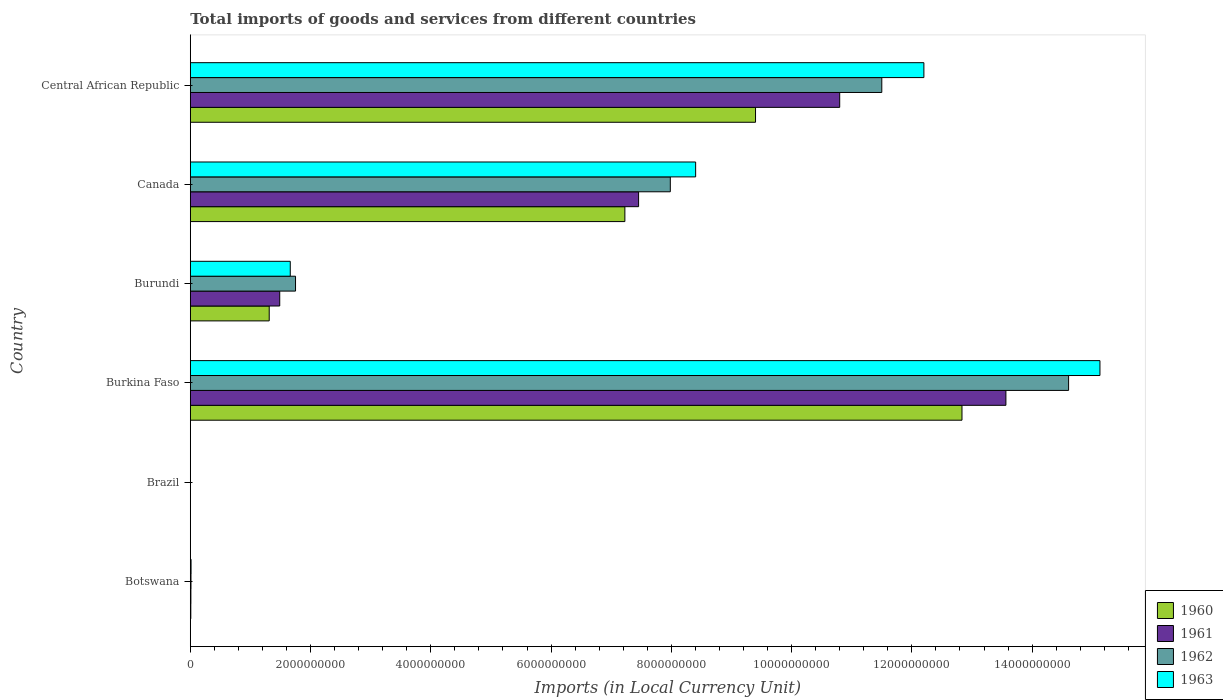How many groups of bars are there?
Keep it short and to the point. 6. How many bars are there on the 3rd tick from the bottom?
Ensure brevity in your answer.  4. What is the label of the 2nd group of bars from the top?
Your answer should be compact. Canada. What is the Amount of goods and services imports in 1963 in Brazil?
Offer a terse response. 0. Across all countries, what is the maximum Amount of goods and services imports in 1960?
Provide a succinct answer. 1.28e+1. Across all countries, what is the minimum Amount of goods and services imports in 1962?
Your response must be concise. 0. In which country was the Amount of goods and services imports in 1960 maximum?
Give a very brief answer. Burkina Faso. What is the total Amount of goods and services imports in 1960 in the graph?
Provide a succinct answer. 3.08e+1. What is the difference between the Amount of goods and services imports in 1960 in Burundi and that in Canada?
Your answer should be compact. -5.91e+09. What is the difference between the Amount of goods and services imports in 1962 in Botswana and the Amount of goods and services imports in 1960 in Burundi?
Offer a very short reply. -1.30e+09. What is the average Amount of goods and services imports in 1961 per country?
Make the answer very short. 5.55e+09. What is the difference between the Amount of goods and services imports in 1961 and Amount of goods and services imports in 1963 in Brazil?
Offer a very short reply. -0. What is the ratio of the Amount of goods and services imports in 1960 in Botswana to that in Burundi?
Provide a short and direct response. 0.01. What is the difference between the highest and the second highest Amount of goods and services imports in 1960?
Offer a very short reply. 3.43e+09. What is the difference between the highest and the lowest Amount of goods and services imports in 1961?
Your response must be concise. 1.36e+1. In how many countries, is the Amount of goods and services imports in 1963 greater than the average Amount of goods and services imports in 1963 taken over all countries?
Give a very brief answer. 3. Is it the case that in every country, the sum of the Amount of goods and services imports in 1960 and Amount of goods and services imports in 1961 is greater than the sum of Amount of goods and services imports in 1963 and Amount of goods and services imports in 1962?
Ensure brevity in your answer.  No. What does the 4th bar from the top in Canada represents?
Give a very brief answer. 1960. Is it the case that in every country, the sum of the Amount of goods and services imports in 1961 and Amount of goods and services imports in 1963 is greater than the Amount of goods and services imports in 1960?
Your answer should be very brief. Yes. How many bars are there?
Offer a terse response. 24. How many countries are there in the graph?
Your response must be concise. 6. What is the difference between two consecutive major ticks on the X-axis?
Your response must be concise. 2.00e+09. Are the values on the major ticks of X-axis written in scientific E-notation?
Keep it short and to the point. No. Does the graph contain any zero values?
Ensure brevity in your answer.  No. Does the graph contain grids?
Offer a very short reply. No. How many legend labels are there?
Offer a terse response. 4. What is the title of the graph?
Your answer should be very brief. Total imports of goods and services from different countries. Does "1997" appear as one of the legend labels in the graph?
Ensure brevity in your answer.  No. What is the label or title of the X-axis?
Offer a terse response. Imports (in Local Currency Unit). What is the label or title of the Y-axis?
Provide a short and direct response. Country. What is the Imports (in Local Currency Unit) of 1960 in Botswana?
Ensure brevity in your answer.  8.60e+06. What is the Imports (in Local Currency Unit) of 1962 in Botswana?
Offer a very short reply. 1.14e+07. What is the Imports (in Local Currency Unit) of 1963 in Botswana?
Offer a terse response. 1.29e+07. What is the Imports (in Local Currency Unit) in 1960 in Brazil?
Keep it short and to the point. 7.33493e-5. What is the Imports (in Local Currency Unit) of 1961 in Brazil?
Offer a terse response. 0. What is the Imports (in Local Currency Unit) of 1962 in Brazil?
Your answer should be very brief. 0. What is the Imports (in Local Currency Unit) in 1963 in Brazil?
Ensure brevity in your answer.  0. What is the Imports (in Local Currency Unit) of 1960 in Burkina Faso?
Ensure brevity in your answer.  1.28e+1. What is the Imports (in Local Currency Unit) of 1961 in Burkina Faso?
Keep it short and to the point. 1.36e+1. What is the Imports (in Local Currency Unit) of 1962 in Burkina Faso?
Your response must be concise. 1.46e+1. What is the Imports (in Local Currency Unit) in 1963 in Burkina Faso?
Your response must be concise. 1.51e+1. What is the Imports (in Local Currency Unit) in 1960 in Burundi?
Your answer should be very brief. 1.31e+09. What is the Imports (in Local Currency Unit) of 1961 in Burundi?
Ensure brevity in your answer.  1.49e+09. What is the Imports (in Local Currency Unit) of 1962 in Burundi?
Your response must be concise. 1.75e+09. What is the Imports (in Local Currency Unit) in 1963 in Burundi?
Give a very brief answer. 1.66e+09. What is the Imports (in Local Currency Unit) in 1960 in Canada?
Ensure brevity in your answer.  7.23e+09. What is the Imports (in Local Currency Unit) in 1961 in Canada?
Make the answer very short. 7.46e+09. What is the Imports (in Local Currency Unit) of 1962 in Canada?
Keep it short and to the point. 7.98e+09. What is the Imports (in Local Currency Unit) of 1963 in Canada?
Offer a terse response. 8.40e+09. What is the Imports (in Local Currency Unit) in 1960 in Central African Republic?
Your answer should be compact. 9.40e+09. What is the Imports (in Local Currency Unit) of 1961 in Central African Republic?
Keep it short and to the point. 1.08e+1. What is the Imports (in Local Currency Unit) in 1962 in Central African Republic?
Your response must be concise. 1.15e+1. What is the Imports (in Local Currency Unit) in 1963 in Central African Republic?
Your answer should be compact. 1.22e+1. Across all countries, what is the maximum Imports (in Local Currency Unit) in 1960?
Keep it short and to the point. 1.28e+1. Across all countries, what is the maximum Imports (in Local Currency Unit) in 1961?
Provide a succinct answer. 1.36e+1. Across all countries, what is the maximum Imports (in Local Currency Unit) in 1962?
Your answer should be very brief. 1.46e+1. Across all countries, what is the maximum Imports (in Local Currency Unit) in 1963?
Give a very brief answer. 1.51e+1. Across all countries, what is the minimum Imports (in Local Currency Unit) of 1960?
Ensure brevity in your answer.  7.33493e-5. Across all countries, what is the minimum Imports (in Local Currency Unit) in 1961?
Ensure brevity in your answer.  0. Across all countries, what is the minimum Imports (in Local Currency Unit) of 1962?
Your response must be concise. 0. Across all countries, what is the minimum Imports (in Local Currency Unit) in 1963?
Provide a short and direct response. 0. What is the total Imports (in Local Currency Unit) in 1960 in the graph?
Your answer should be compact. 3.08e+1. What is the total Imports (in Local Currency Unit) of 1961 in the graph?
Make the answer very short. 3.33e+1. What is the total Imports (in Local Currency Unit) of 1962 in the graph?
Give a very brief answer. 3.59e+1. What is the total Imports (in Local Currency Unit) of 1963 in the graph?
Your answer should be very brief. 3.74e+1. What is the difference between the Imports (in Local Currency Unit) of 1960 in Botswana and that in Brazil?
Make the answer very short. 8.60e+06. What is the difference between the Imports (in Local Currency Unit) in 1961 in Botswana and that in Brazil?
Your response must be concise. 1.00e+07. What is the difference between the Imports (in Local Currency Unit) in 1962 in Botswana and that in Brazil?
Make the answer very short. 1.14e+07. What is the difference between the Imports (in Local Currency Unit) of 1963 in Botswana and that in Brazil?
Your answer should be very brief. 1.29e+07. What is the difference between the Imports (in Local Currency Unit) in 1960 in Botswana and that in Burkina Faso?
Provide a short and direct response. -1.28e+1. What is the difference between the Imports (in Local Currency Unit) of 1961 in Botswana and that in Burkina Faso?
Keep it short and to the point. -1.36e+1. What is the difference between the Imports (in Local Currency Unit) of 1962 in Botswana and that in Burkina Faso?
Your response must be concise. -1.46e+1. What is the difference between the Imports (in Local Currency Unit) in 1963 in Botswana and that in Burkina Faso?
Provide a succinct answer. -1.51e+1. What is the difference between the Imports (in Local Currency Unit) of 1960 in Botswana and that in Burundi?
Give a very brief answer. -1.30e+09. What is the difference between the Imports (in Local Currency Unit) of 1961 in Botswana and that in Burundi?
Ensure brevity in your answer.  -1.48e+09. What is the difference between the Imports (in Local Currency Unit) in 1962 in Botswana and that in Burundi?
Provide a short and direct response. -1.74e+09. What is the difference between the Imports (in Local Currency Unit) in 1963 in Botswana and that in Burundi?
Give a very brief answer. -1.65e+09. What is the difference between the Imports (in Local Currency Unit) in 1960 in Botswana and that in Canada?
Make the answer very short. -7.22e+09. What is the difference between the Imports (in Local Currency Unit) in 1961 in Botswana and that in Canada?
Ensure brevity in your answer.  -7.45e+09. What is the difference between the Imports (in Local Currency Unit) in 1962 in Botswana and that in Canada?
Your answer should be very brief. -7.97e+09. What is the difference between the Imports (in Local Currency Unit) in 1963 in Botswana and that in Canada?
Your answer should be very brief. -8.39e+09. What is the difference between the Imports (in Local Currency Unit) in 1960 in Botswana and that in Central African Republic?
Keep it short and to the point. -9.39e+09. What is the difference between the Imports (in Local Currency Unit) in 1961 in Botswana and that in Central African Republic?
Offer a terse response. -1.08e+1. What is the difference between the Imports (in Local Currency Unit) in 1962 in Botswana and that in Central African Republic?
Offer a very short reply. -1.15e+1. What is the difference between the Imports (in Local Currency Unit) in 1963 in Botswana and that in Central African Republic?
Ensure brevity in your answer.  -1.22e+1. What is the difference between the Imports (in Local Currency Unit) in 1960 in Brazil and that in Burkina Faso?
Provide a succinct answer. -1.28e+1. What is the difference between the Imports (in Local Currency Unit) of 1961 in Brazil and that in Burkina Faso?
Provide a succinct answer. -1.36e+1. What is the difference between the Imports (in Local Currency Unit) in 1962 in Brazil and that in Burkina Faso?
Give a very brief answer. -1.46e+1. What is the difference between the Imports (in Local Currency Unit) of 1963 in Brazil and that in Burkina Faso?
Offer a terse response. -1.51e+1. What is the difference between the Imports (in Local Currency Unit) in 1960 in Brazil and that in Burundi?
Provide a succinct answer. -1.31e+09. What is the difference between the Imports (in Local Currency Unit) of 1961 in Brazil and that in Burundi?
Provide a short and direct response. -1.49e+09. What is the difference between the Imports (in Local Currency Unit) in 1962 in Brazil and that in Burundi?
Offer a terse response. -1.75e+09. What is the difference between the Imports (in Local Currency Unit) in 1963 in Brazil and that in Burundi?
Offer a very short reply. -1.66e+09. What is the difference between the Imports (in Local Currency Unit) of 1960 in Brazil and that in Canada?
Make the answer very short. -7.23e+09. What is the difference between the Imports (in Local Currency Unit) in 1961 in Brazil and that in Canada?
Offer a very short reply. -7.46e+09. What is the difference between the Imports (in Local Currency Unit) in 1962 in Brazil and that in Canada?
Offer a terse response. -7.98e+09. What is the difference between the Imports (in Local Currency Unit) in 1963 in Brazil and that in Canada?
Make the answer very short. -8.40e+09. What is the difference between the Imports (in Local Currency Unit) in 1960 in Brazil and that in Central African Republic?
Provide a succinct answer. -9.40e+09. What is the difference between the Imports (in Local Currency Unit) of 1961 in Brazil and that in Central African Republic?
Provide a short and direct response. -1.08e+1. What is the difference between the Imports (in Local Currency Unit) of 1962 in Brazil and that in Central African Republic?
Your answer should be compact. -1.15e+1. What is the difference between the Imports (in Local Currency Unit) of 1963 in Brazil and that in Central African Republic?
Give a very brief answer. -1.22e+1. What is the difference between the Imports (in Local Currency Unit) in 1960 in Burkina Faso and that in Burundi?
Offer a terse response. 1.15e+1. What is the difference between the Imports (in Local Currency Unit) in 1961 in Burkina Faso and that in Burundi?
Your response must be concise. 1.21e+1. What is the difference between the Imports (in Local Currency Unit) of 1962 in Burkina Faso and that in Burundi?
Provide a short and direct response. 1.29e+1. What is the difference between the Imports (in Local Currency Unit) of 1963 in Burkina Faso and that in Burundi?
Offer a terse response. 1.35e+1. What is the difference between the Imports (in Local Currency Unit) of 1960 in Burkina Faso and that in Canada?
Offer a terse response. 5.61e+09. What is the difference between the Imports (in Local Currency Unit) of 1961 in Burkina Faso and that in Canada?
Your answer should be compact. 6.11e+09. What is the difference between the Imports (in Local Currency Unit) in 1962 in Burkina Faso and that in Canada?
Provide a succinct answer. 6.62e+09. What is the difference between the Imports (in Local Currency Unit) of 1963 in Burkina Faso and that in Canada?
Ensure brevity in your answer.  6.72e+09. What is the difference between the Imports (in Local Currency Unit) of 1960 in Burkina Faso and that in Central African Republic?
Offer a terse response. 3.43e+09. What is the difference between the Imports (in Local Currency Unit) of 1961 in Burkina Faso and that in Central African Republic?
Your answer should be very brief. 2.76e+09. What is the difference between the Imports (in Local Currency Unit) of 1962 in Burkina Faso and that in Central African Republic?
Offer a terse response. 3.11e+09. What is the difference between the Imports (in Local Currency Unit) of 1963 in Burkina Faso and that in Central African Republic?
Keep it short and to the point. 2.93e+09. What is the difference between the Imports (in Local Currency Unit) of 1960 in Burundi and that in Canada?
Your response must be concise. -5.91e+09. What is the difference between the Imports (in Local Currency Unit) in 1961 in Burundi and that in Canada?
Offer a very short reply. -5.97e+09. What is the difference between the Imports (in Local Currency Unit) of 1962 in Burundi and that in Canada?
Give a very brief answer. -6.23e+09. What is the difference between the Imports (in Local Currency Unit) in 1963 in Burundi and that in Canada?
Give a very brief answer. -6.74e+09. What is the difference between the Imports (in Local Currency Unit) of 1960 in Burundi and that in Central African Republic?
Offer a terse response. -8.09e+09. What is the difference between the Imports (in Local Currency Unit) in 1961 in Burundi and that in Central African Republic?
Give a very brief answer. -9.31e+09. What is the difference between the Imports (in Local Currency Unit) in 1962 in Burundi and that in Central African Republic?
Offer a terse response. -9.75e+09. What is the difference between the Imports (in Local Currency Unit) of 1963 in Burundi and that in Central African Republic?
Your answer should be very brief. -1.05e+1. What is the difference between the Imports (in Local Currency Unit) in 1960 in Canada and that in Central African Republic?
Your answer should be compact. -2.17e+09. What is the difference between the Imports (in Local Currency Unit) of 1961 in Canada and that in Central African Republic?
Offer a very short reply. -3.34e+09. What is the difference between the Imports (in Local Currency Unit) of 1962 in Canada and that in Central African Republic?
Your answer should be very brief. -3.52e+09. What is the difference between the Imports (in Local Currency Unit) in 1963 in Canada and that in Central African Republic?
Your answer should be compact. -3.80e+09. What is the difference between the Imports (in Local Currency Unit) in 1960 in Botswana and the Imports (in Local Currency Unit) in 1961 in Brazil?
Your answer should be compact. 8.60e+06. What is the difference between the Imports (in Local Currency Unit) in 1960 in Botswana and the Imports (in Local Currency Unit) in 1962 in Brazil?
Make the answer very short. 8.60e+06. What is the difference between the Imports (in Local Currency Unit) of 1960 in Botswana and the Imports (in Local Currency Unit) of 1963 in Brazil?
Offer a terse response. 8.60e+06. What is the difference between the Imports (in Local Currency Unit) of 1961 in Botswana and the Imports (in Local Currency Unit) of 1962 in Brazil?
Offer a terse response. 1.00e+07. What is the difference between the Imports (in Local Currency Unit) of 1961 in Botswana and the Imports (in Local Currency Unit) of 1963 in Brazil?
Make the answer very short. 1.00e+07. What is the difference between the Imports (in Local Currency Unit) of 1962 in Botswana and the Imports (in Local Currency Unit) of 1963 in Brazil?
Offer a terse response. 1.14e+07. What is the difference between the Imports (in Local Currency Unit) in 1960 in Botswana and the Imports (in Local Currency Unit) in 1961 in Burkina Faso?
Make the answer very short. -1.36e+1. What is the difference between the Imports (in Local Currency Unit) of 1960 in Botswana and the Imports (in Local Currency Unit) of 1962 in Burkina Faso?
Ensure brevity in your answer.  -1.46e+1. What is the difference between the Imports (in Local Currency Unit) in 1960 in Botswana and the Imports (in Local Currency Unit) in 1963 in Burkina Faso?
Ensure brevity in your answer.  -1.51e+1. What is the difference between the Imports (in Local Currency Unit) of 1961 in Botswana and the Imports (in Local Currency Unit) of 1962 in Burkina Faso?
Make the answer very short. -1.46e+1. What is the difference between the Imports (in Local Currency Unit) in 1961 in Botswana and the Imports (in Local Currency Unit) in 1963 in Burkina Faso?
Provide a succinct answer. -1.51e+1. What is the difference between the Imports (in Local Currency Unit) of 1962 in Botswana and the Imports (in Local Currency Unit) of 1963 in Burkina Faso?
Ensure brevity in your answer.  -1.51e+1. What is the difference between the Imports (in Local Currency Unit) of 1960 in Botswana and the Imports (in Local Currency Unit) of 1961 in Burundi?
Your answer should be very brief. -1.48e+09. What is the difference between the Imports (in Local Currency Unit) of 1960 in Botswana and the Imports (in Local Currency Unit) of 1962 in Burundi?
Your response must be concise. -1.74e+09. What is the difference between the Imports (in Local Currency Unit) of 1960 in Botswana and the Imports (in Local Currency Unit) of 1963 in Burundi?
Give a very brief answer. -1.65e+09. What is the difference between the Imports (in Local Currency Unit) of 1961 in Botswana and the Imports (in Local Currency Unit) of 1962 in Burundi?
Provide a succinct answer. -1.74e+09. What is the difference between the Imports (in Local Currency Unit) in 1961 in Botswana and the Imports (in Local Currency Unit) in 1963 in Burundi?
Provide a succinct answer. -1.65e+09. What is the difference between the Imports (in Local Currency Unit) of 1962 in Botswana and the Imports (in Local Currency Unit) of 1963 in Burundi?
Your response must be concise. -1.65e+09. What is the difference between the Imports (in Local Currency Unit) in 1960 in Botswana and the Imports (in Local Currency Unit) in 1961 in Canada?
Ensure brevity in your answer.  -7.45e+09. What is the difference between the Imports (in Local Currency Unit) of 1960 in Botswana and the Imports (in Local Currency Unit) of 1962 in Canada?
Your answer should be compact. -7.97e+09. What is the difference between the Imports (in Local Currency Unit) in 1960 in Botswana and the Imports (in Local Currency Unit) in 1963 in Canada?
Give a very brief answer. -8.40e+09. What is the difference between the Imports (in Local Currency Unit) of 1961 in Botswana and the Imports (in Local Currency Unit) of 1962 in Canada?
Give a very brief answer. -7.97e+09. What is the difference between the Imports (in Local Currency Unit) of 1961 in Botswana and the Imports (in Local Currency Unit) of 1963 in Canada?
Offer a very short reply. -8.39e+09. What is the difference between the Imports (in Local Currency Unit) in 1962 in Botswana and the Imports (in Local Currency Unit) in 1963 in Canada?
Ensure brevity in your answer.  -8.39e+09. What is the difference between the Imports (in Local Currency Unit) of 1960 in Botswana and the Imports (in Local Currency Unit) of 1961 in Central African Republic?
Make the answer very short. -1.08e+1. What is the difference between the Imports (in Local Currency Unit) in 1960 in Botswana and the Imports (in Local Currency Unit) in 1962 in Central African Republic?
Offer a terse response. -1.15e+1. What is the difference between the Imports (in Local Currency Unit) of 1960 in Botswana and the Imports (in Local Currency Unit) of 1963 in Central African Republic?
Ensure brevity in your answer.  -1.22e+1. What is the difference between the Imports (in Local Currency Unit) in 1961 in Botswana and the Imports (in Local Currency Unit) in 1962 in Central African Republic?
Your response must be concise. -1.15e+1. What is the difference between the Imports (in Local Currency Unit) in 1961 in Botswana and the Imports (in Local Currency Unit) in 1963 in Central African Republic?
Make the answer very short. -1.22e+1. What is the difference between the Imports (in Local Currency Unit) in 1962 in Botswana and the Imports (in Local Currency Unit) in 1963 in Central African Republic?
Provide a short and direct response. -1.22e+1. What is the difference between the Imports (in Local Currency Unit) of 1960 in Brazil and the Imports (in Local Currency Unit) of 1961 in Burkina Faso?
Your response must be concise. -1.36e+1. What is the difference between the Imports (in Local Currency Unit) of 1960 in Brazil and the Imports (in Local Currency Unit) of 1962 in Burkina Faso?
Provide a succinct answer. -1.46e+1. What is the difference between the Imports (in Local Currency Unit) of 1960 in Brazil and the Imports (in Local Currency Unit) of 1963 in Burkina Faso?
Your answer should be very brief. -1.51e+1. What is the difference between the Imports (in Local Currency Unit) in 1961 in Brazil and the Imports (in Local Currency Unit) in 1962 in Burkina Faso?
Provide a succinct answer. -1.46e+1. What is the difference between the Imports (in Local Currency Unit) in 1961 in Brazil and the Imports (in Local Currency Unit) in 1963 in Burkina Faso?
Provide a short and direct response. -1.51e+1. What is the difference between the Imports (in Local Currency Unit) in 1962 in Brazil and the Imports (in Local Currency Unit) in 1963 in Burkina Faso?
Your response must be concise. -1.51e+1. What is the difference between the Imports (in Local Currency Unit) in 1960 in Brazil and the Imports (in Local Currency Unit) in 1961 in Burundi?
Offer a very short reply. -1.49e+09. What is the difference between the Imports (in Local Currency Unit) in 1960 in Brazil and the Imports (in Local Currency Unit) in 1962 in Burundi?
Your answer should be very brief. -1.75e+09. What is the difference between the Imports (in Local Currency Unit) in 1960 in Brazil and the Imports (in Local Currency Unit) in 1963 in Burundi?
Ensure brevity in your answer.  -1.66e+09. What is the difference between the Imports (in Local Currency Unit) in 1961 in Brazil and the Imports (in Local Currency Unit) in 1962 in Burundi?
Offer a very short reply. -1.75e+09. What is the difference between the Imports (in Local Currency Unit) of 1961 in Brazil and the Imports (in Local Currency Unit) of 1963 in Burundi?
Make the answer very short. -1.66e+09. What is the difference between the Imports (in Local Currency Unit) in 1962 in Brazil and the Imports (in Local Currency Unit) in 1963 in Burundi?
Your response must be concise. -1.66e+09. What is the difference between the Imports (in Local Currency Unit) in 1960 in Brazil and the Imports (in Local Currency Unit) in 1961 in Canada?
Give a very brief answer. -7.46e+09. What is the difference between the Imports (in Local Currency Unit) of 1960 in Brazil and the Imports (in Local Currency Unit) of 1962 in Canada?
Offer a terse response. -7.98e+09. What is the difference between the Imports (in Local Currency Unit) of 1960 in Brazil and the Imports (in Local Currency Unit) of 1963 in Canada?
Provide a succinct answer. -8.40e+09. What is the difference between the Imports (in Local Currency Unit) of 1961 in Brazil and the Imports (in Local Currency Unit) of 1962 in Canada?
Provide a short and direct response. -7.98e+09. What is the difference between the Imports (in Local Currency Unit) in 1961 in Brazil and the Imports (in Local Currency Unit) in 1963 in Canada?
Ensure brevity in your answer.  -8.40e+09. What is the difference between the Imports (in Local Currency Unit) of 1962 in Brazil and the Imports (in Local Currency Unit) of 1963 in Canada?
Your answer should be compact. -8.40e+09. What is the difference between the Imports (in Local Currency Unit) in 1960 in Brazil and the Imports (in Local Currency Unit) in 1961 in Central African Republic?
Make the answer very short. -1.08e+1. What is the difference between the Imports (in Local Currency Unit) in 1960 in Brazil and the Imports (in Local Currency Unit) in 1962 in Central African Republic?
Keep it short and to the point. -1.15e+1. What is the difference between the Imports (in Local Currency Unit) in 1960 in Brazil and the Imports (in Local Currency Unit) in 1963 in Central African Republic?
Give a very brief answer. -1.22e+1. What is the difference between the Imports (in Local Currency Unit) in 1961 in Brazil and the Imports (in Local Currency Unit) in 1962 in Central African Republic?
Give a very brief answer. -1.15e+1. What is the difference between the Imports (in Local Currency Unit) in 1961 in Brazil and the Imports (in Local Currency Unit) in 1963 in Central African Republic?
Offer a terse response. -1.22e+1. What is the difference between the Imports (in Local Currency Unit) in 1962 in Brazil and the Imports (in Local Currency Unit) in 1963 in Central African Republic?
Give a very brief answer. -1.22e+1. What is the difference between the Imports (in Local Currency Unit) in 1960 in Burkina Faso and the Imports (in Local Currency Unit) in 1961 in Burundi?
Your response must be concise. 1.13e+1. What is the difference between the Imports (in Local Currency Unit) in 1960 in Burkina Faso and the Imports (in Local Currency Unit) in 1962 in Burundi?
Your answer should be compact. 1.11e+1. What is the difference between the Imports (in Local Currency Unit) of 1960 in Burkina Faso and the Imports (in Local Currency Unit) of 1963 in Burundi?
Provide a short and direct response. 1.12e+1. What is the difference between the Imports (in Local Currency Unit) of 1961 in Burkina Faso and the Imports (in Local Currency Unit) of 1962 in Burundi?
Ensure brevity in your answer.  1.18e+1. What is the difference between the Imports (in Local Currency Unit) of 1961 in Burkina Faso and the Imports (in Local Currency Unit) of 1963 in Burundi?
Offer a terse response. 1.19e+1. What is the difference between the Imports (in Local Currency Unit) in 1962 in Burkina Faso and the Imports (in Local Currency Unit) in 1963 in Burundi?
Provide a succinct answer. 1.29e+1. What is the difference between the Imports (in Local Currency Unit) in 1960 in Burkina Faso and the Imports (in Local Currency Unit) in 1961 in Canada?
Keep it short and to the point. 5.38e+09. What is the difference between the Imports (in Local Currency Unit) of 1960 in Burkina Faso and the Imports (in Local Currency Unit) of 1962 in Canada?
Your response must be concise. 4.85e+09. What is the difference between the Imports (in Local Currency Unit) of 1960 in Burkina Faso and the Imports (in Local Currency Unit) of 1963 in Canada?
Provide a short and direct response. 4.43e+09. What is the difference between the Imports (in Local Currency Unit) in 1961 in Burkina Faso and the Imports (in Local Currency Unit) in 1962 in Canada?
Your answer should be very brief. 5.58e+09. What is the difference between the Imports (in Local Currency Unit) of 1961 in Burkina Faso and the Imports (in Local Currency Unit) of 1963 in Canada?
Provide a short and direct response. 5.16e+09. What is the difference between the Imports (in Local Currency Unit) of 1962 in Burkina Faso and the Imports (in Local Currency Unit) of 1963 in Canada?
Provide a succinct answer. 6.20e+09. What is the difference between the Imports (in Local Currency Unit) in 1960 in Burkina Faso and the Imports (in Local Currency Unit) in 1961 in Central African Republic?
Your answer should be compact. 2.03e+09. What is the difference between the Imports (in Local Currency Unit) of 1960 in Burkina Faso and the Imports (in Local Currency Unit) of 1962 in Central African Republic?
Offer a terse response. 1.33e+09. What is the difference between the Imports (in Local Currency Unit) in 1960 in Burkina Faso and the Imports (in Local Currency Unit) in 1963 in Central African Republic?
Your response must be concise. 6.34e+08. What is the difference between the Imports (in Local Currency Unit) of 1961 in Burkina Faso and the Imports (in Local Currency Unit) of 1962 in Central African Republic?
Provide a succinct answer. 2.06e+09. What is the difference between the Imports (in Local Currency Unit) of 1961 in Burkina Faso and the Imports (in Local Currency Unit) of 1963 in Central African Republic?
Give a very brief answer. 1.36e+09. What is the difference between the Imports (in Local Currency Unit) of 1962 in Burkina Faso and the Imports (in Local Currency Unit) of 1963 in Central African Republic?
Your answer should be very brief. 2.41e+09. What is the difference between the Imports (in Local Currency Unit) in 1960 in Burundi and the Imports (in Local Currency Unit) in 1961 in Canada?
Your response must be concise. -6.14e+09. What is the difference between the Imports (in Local Currency Unit) of 1960 in Burundi and the Imports (in Local Currency Unit) of 1962 in Canada?
Offer a terse response. -6.67e+09. What is the difference between the Imports (in Local Currency Unit) in 1960 in Burundi and the Imports (in Local Currency Unit) in 1963 in Canada?
Provide a short and direct response. -7.09e+09. What is the difference between the Imports (in Local Currency Unit) in 1961 in Burundi and the Imports (in Local Currency Unit) in 1962 in Canada?
Your answer should be compact. -6.50e+09. What is the difference between the Imports (in Local Currency Unit) in 1961 in Burundi and the Imports (in Local Currency Unit) in 1963 in Canada?
Your answer should be very brief. -6.92e+09. What is the difference between the Imports (in Local Currency Unit) in 1962 in Burundi and the Imports (in Local Currency Unit) in 1963 in Canada?
Your answer should be very brief. -6.65e+09. What is the difference between the Imports (in Local Currency Unit) in 1960 in Burundi and the Imports (in Local Currency Unit) in 1961 in Central African Republic?
Make the answer very short. -9.49e+09. What is the difference between the Imports (in Local Currency Unit) of 1960 in Burundi and the Imports (in Local Currency Unit) of 1962 in Central African Republic?
Your answer should be very brief. -1.02e+1. What is the difference between the Imports (in Local Currency Unit) in 1960 in Burundi and the Imports (in Local Currency Unit) in 1963 in Central African Republic?
Your answer should be compact. -1.09e+1. What is the difference between the Imports (in Local Currency Unit) of 1961 in Burundi and the Imports (in Local Currency Unit) of 1962 in Central African Republic?
Ensure brevity in your answer.  -1.00e+1. What is the difference between the Imports (in Local Currency Unit) of 1961 in Burundi and the Imports (in Local Currency Unit) of 1963 in Central African Republic?
Offer a terse response. -1.07e+1. What is the difference between the Imports (in Local Currency Unit) of 1962 in Burundi and the Imports (in Local Currency Unit) of 1963 in Central African Republic?
Your answer should be very brief. -1.05e+1. What is the difference between the Imports (in Local Currency Unit) of 1960 in Canada and the Imports (in Local Currency Unit) of 1961 in Central African Republic?
Your response must be concise. -3.57e+09. What is the difference between the Imports (in Local Currency Unit) in 1960 in Canada and the Imports (in Local Currency Unit) in 1962 in Central African Republic?
Your answer should be compact. -4.27e+09. What is the difference between the Imports (in Local Currency Unit) in 1960 in Canada and the Imports (in Local Currency Unit) in 1963 in Central African Republic?
Ensure brevity in your answer.  -4.97e+09. What is the difference between the Imports (in Local Currency Unit) of 1961 in Canada and the Imports (in Local Currency Unit) of 1962 in Central African Republic?
Your answer should be very brief. -4.04e+09. What is the difference between the Imports (in Local Currency Unit) of 1961 in Canada and the Imports (in Local Currency Unit) of 1963 in Central African Republic?
Your answer should be compact. -4.74e+09. What is the difference between the Imports (in Local Currency Unit) of 1962 in Canada and the Imports (in Local Currency Unit) of 1963 in Central African Republic?
Offer a terse response. -4.22e+09. What is the average Imports (in Local Currency Unit) in 1960 per country?
Provide a succinct answer. 5.13e+09. What is the average Imports (in Local Currency Unit) in 1961 per country?
Provide a succinct answer. 5.55e+09. What is the average Imports (in Local Currency Unit) in 1962 per country?
Your answer should be compact. 5.98e+09. What is the average Imports (in Local Currency Unit) in 1963 per country?
Offer a terse response. 6.23e+09. What is the difference between the Imports (in Local Currency Unit) in 1960 and Imports (in Local Currency Unit) in 1961 in Botswana?
Your answer should be very brief. -1.40e+06. What is the difference between the Imports (in Local Currency Unit) of 1960 and Imports (in Local Currency Unit) of 1962 in Botswana?
Your response must be concise. -2.80e+06. What is the difference between the Imports (in Local Currency Unit) of 1960 and Imports (in Local Currency Unit) of 1963 in Botswana?
Offer a very short reply. -4.30e+06. What is the difference between the Imports (in Local Currency Unit) of 1961 and Imports (in Local Currency Unit) of 1962 in Botswana?
Ensure brevity in your answer.  -1.40e+06. What is the difference between the Imports (in Local Currency Unit) of 1961 and Imports (in Local Currency Unit) of 1963 in Botswana?
Ensure brevity in your answer.  -2.90e+06. What is the difference between the Imports (in Local Currency Unit) in 1962 and Imports (in Local Currency Unit) in 1963 in Botswana?
Give a very brief answer. -1.50e+06. What is the difference between the Imports (in Local Currency Unit) of 1960 and Imports (in Local Currency Unit) of 1961 in Brazil?
Give a very brief answer. -0. What is the difference between the Imports (in Local Currency Unit) of 1960 and Imports (in Local Currency Unit) of 1962 in Brazil?
Offer a very short reply. -0. What is the difference between the Imports (in Local Currency Unit) of 1960 and Imports (in Local Currency Unit) of 1963 in Brazil?
Ensure brevity in your answer.  -0. What is the difference between the Imports (in Local Currency Unit) of 1961 and Imports (in Local Currency Unit) of 1963 in Brazil?
Give a very brief answer. -0. What is the difference between the Imports (in Local Currency Unit) in 1962 and Imports (in Local Currency Unit) in 1963 in Brazil?
Give a very brief answer. -0. What is the difference between the Imports (in Local Currency Unit) of 1960 and Imports (in Local Currency Unit) of 1961 in Burkina Faso?
Offer a very short reply. -7.30e+08. What is the difference between the Imports (in Local Currency Unit) of 1960 and Imports (in Local Currency Unit) of 1962 in Burkina Faso?
Ensure brevity in your answer.  -1.77e+09. What is the difference between the Imports (in Local Currency Unit) in 1960 and Imports (in Local Currency Unit) in 1963 in Burkina Faso?
Your answer should be compact. -2.29e+09. What is the difference between the Imports (in Local Currency Unit) of 1961 and Imports (in Local Currency Unit) of 1962 in Burkina Faso?
Offer a terse response. -1.04e+09. What is the difference between the Imports (in Local Currency Unit) in 1961 and Imports (in Local Currency Unit) in 1963 in Burkina Faso?
Offer a terse response. -1.56e+09. What is the difference between the Imports (in Local Currency Unit) of 1962 and Imports (in Local Currency Unit) of 1963 in Burkina Faso?
Your answer should be compact. -5.21e+08. What is the difference between the Imports (in Local Currency Unit) in 1960 and Imports (in Local Currency Unit) in 1961 in Burundi?
Your response must be concise. -1.75e+08. What is the difference between the Imports (in Local Currency Unit) of 1960 and Imports (in Local Currency Unit) of 1962 in Burundi?
Give a very brief answer. -4.38e+08. What is the difference between the Imports (in Local Currency Unit) of 1960 and Imports (in Local Currency Unit) of 1963 in Burundi?
Offer a terse response. -3.50e+08. What is the difference between the Imports (in Local Currency Unit) in 1961 and Imports (in Local Currency Unit) in 1962 in Burundi?
Offer a very short reply. -2.62e+08. What is the difference between the Imports (in Local Currency Unit) of 1961 and Imports (in Local Currency Unit) of 1963 in Burundi?
Ensure brevity in your answer.  -1.75e+08. What is the difference between the Imports (in Local Currency Unit) of 1962 and Imports (in Local Currency Unit) of 1963 in Burundi?
Keep it short and to the point. 8.75e+07. What is the difference between the Imports (in Local Currency Unit) in 1960 and Imports (in Local Currency Unit) in 1961 in Canada?
Offer a terse response. -2.28e+08. What is the difference between the Imports (in Local Currency Unit) of 1960 and Imports (in Local Currency Unit) of 1962 in Canada?
Your answer should be compact. -7.56e+08. What is the difference between the Imports (in Local Currency Unit) in 1960 and Imports (in Local Currency Unit) in 1963 in Canada?
Ensure brevity in your answer.  -1.18e+09. What is the difference between the Imports (in Local Currency Unit) of 1961 and Imports (in Local Currency Unit) of 1962 in Canada?
Provide a short and direct response. -5.27e+08. What is the difference between the Imports (in Local Currency Unit) in 1961 and Imports (in Local Currency Unit) in 1963 in Canada?
Ensure brevity in your answer.  -9.49e+08. What is the difference between the Imports (in Local Currency Unit) in 1962 and Imports (in Local Currency Unit) in 1963 in Canada?
Your answer should be very brief. -4.21e+08. What is the difference between the Imports (in Local Currency Unit) in 1960 and Imports (in Local Currency Unit) in 1961 in Central African Republic?
Provide a short and direct response. -1.40e+09. What is the difference between the Imports (in Local Currency Unit) of 1960 and Imports (in Local Currency Unit) of 1962 in Central African Republic?
Keep it short and to the point. -2.10e+09. What is the difference between the Imports (in Local Currency Unit) in 1960 and Imports (in Local Currency Unit) in 1963 in Central African Republic?
Your response must be concise. -2.80e+09. What is the difference between the Imports (in Local Currency Unit) in 1961 and Imports (in Local Currency Unit) in 1962 in Central African Republic?
Give a very brief answer. -7.00e+08. What is the difference between the Imports (in Local Currency Unit) in 1961 and Imports (in Local Currency Unit) in 1963 in Central African Republic?
Provide a short and direct response. -1.40e+09. What is the difference between the Imports (in Local Currency Unit) of 1962 and Imports (in Local Currency Unit) of 1963 in Central African Republic?
Provide a succinct answer. -7.00e+08. What is the ratio of the Imports (in Local Currency Unit) of 1960 in Botswana to that in Brazil?
Your answer should be compact. 1.17e+11. What is the ratio of the Imports (in Local Currency Unit) of 1961 in Botswana to that in Brazil?
Provide a short and direct response. 9.13e+1. What is the ratio of the Imports (in Local Currency Unit) of 1962 in Botswana to that in Brazil?
Make the answer very short. 7.82e+1. What is the ratio of the Imports (in Local Currency Unit) of 1963 in Botswana to that in Brazil?
Give a very brief answer. 2.94e+1. What is the ratio of the Imports (in Local Currency Unit) in 1960 in Botswana to that in Burkina Faso?
Provide a succinct answer. 0. What is the ratio of the Imports (in Local Currency Unit) of 1961 in Botswana to that in Burkina Faso?
Provide a succinct answer. 0. What is the ratio of the Imports (in Local Currency Unit) in 1962 in Botswana to that in Burkina Faso?
Your answer should be very brief. 0. What is the ratio of the Imports (in Local Currency Unit) in 1963 in Botswana to that in Burkina Faso?
Your answer should be very brief. 0. What is the ratio of the Imports (in Local Currency Unit) of 1960 in Botswana to that in Burundi?
Your answer should be very brief. 0.01. What is the ratio of the Imports (in Local Currency Unit) in 1961 in Botswana to that in Burundi?
Your answer should be very brief. 0.01. What is the ratio of the Imports (in Local Currency Unit) of 1962 in Botswana to that in Burundi?
Offer a terse response. 0.01. What is the ratio of the Imports (in Local Currency Unit) of 1963 in Botswana to that in Burundi?
Offer a very short reply. 0.01. What is the ratio of the Imports (in Local Currency Unit) in 1960 in Botswana to that in Canada?
Make the answer very short. 0. What is the ratio of the Imports (in Local Currency Unit) of 1961 in Botswana to that in Canada?
Provide a short and direct response. 0. What is the ratio of the Imports (in Local Currency Unit) of 1962 in Botswana to that in Canada?
Ensure brevity in your answer.  0. What is the ratio of the Imports (in Local Currency Unit) in 1963 in Botswana to that in Canada?
Give a very brief answer. 0. What is the ratio of the Imports (in Local Currency Unit) of 1960 in Botswana to that in Central African Republic?
Ensure brevity in your answer.  0. What is the ratio of the Imports (in Local Currency Unit) of 1961 in Botswana to that in Central African Republic?
Give a very brief answer. 0. What is the ratio of the Imports (in Local Currency Unit) in 1962 in Botswana to that in Central African Republic?
Offer a terse response. 0. What is the ratio of the Imports (in Local Currency Unit) of 1963 in Botswana to that in Central African Republic?
Provide a succinct answer. 0. What is the ratio of the Imports (in Local Currency Unit) of 1960 in Brazil to that in Burkina Faso?
Your response must be concise. 0. What is the ratio of the Imports (in Local Currency Unit) in 1961 in Brazil to that in Burkina Faso?
Provide a succinct answer. 0. What is the ratio of the Imports (in Local Currency Unit) in 1962 in Brazil to that in Burkina Faso?
Provide a succinct answer. 0. What is the ratio of the Imports (in Local Currency Unit) in 1960 in Brazil to that in Burundi?
Provide a succinct answer. 0. What is the ratio of the Imports (in Local Currency Unit) of 1961 in Brazil to that in Burundi?
Provide a succinct answer. 0. What is the ratio of the Imports (in Local Currency Unit) of 1961 in Brazil to that in Canada?
Provide a succinct answer. 0. What is the ratio of the Imports (in Local Currency Unit) of 1962 in Brazil to that in Canada?
Ensure brevity in your answer.  0. What is the ratio of the Imports (in Local Currency Unit) in 1963 in Brazil to that in Canada?
Your answer should be very brief. 0. What is the ratio of the Imports (in Local Currency Unit) in 1960 in Brazil to that in Central African Republic?
Your answer should be very brief. 0. What is the ratio of the Imports (in Local Currency Unit) in 1962 in Brazil to that in Central African Republic?
Provide a succinct answer. 0. What is the ratio of the Imports (in Local Currency Unit) in 1963 in Brazil to that in Central African Republic?
Keep it short and to the point. 0. What is the ratio of the Imports (in Local Currency Unit) of 1960 in Burkina Faso to that in Burundi?
Offer a very short reply. 9.78. What is the ratio of the Imports (in Local Currency Unit) in 1961 in Burkina Faso to that in Burundi?
Make the answer very short. 9.12. What is the ratio of the Imports (in Local Currency Unit) in 1962 in Burkina Faso to that in Burundi?
Provide a short and direct response. 8.35. What is the ratio of the Imports (in Local Currency Unit) of 1963 in Burkina Faso to that in Burundi?
Your response must be concise. 9.1. What is the ratio of the Imports (in Local Currency Unit) in 1960 in Burkina Faso to that in Canada?
Keep it short and to the point. 1.78. What is the ratio of the Imports (in Local Currency Unit) in 1961 in Burkina Faso to that in Canada?
Give a very brief answer. 1.82. What is the ratio of the Imports (in Local Currency Unit) of 1962 in Burkina Faso to that in Canada?
Provide a short and direct response. 1.83. What is the ratio of the Imports (in Local Currency Unit) in 1963 in Burkina Faso to that in Canada?
Offer a terse response. 1.8. What is the ratio of the Imports (in Local Currency Unit) of 1960 in Burkina Faso to that in Central African Republic?
Ensure brevity in your answer.  1.37. What is the ratio of the Imports (in Local Currency Unit) in 1961 in Burkina Faso to that in Central African Republic?
Ensure brevity in your answer.  1.26. What is the ratio of the Imports (in Local Currency Unit) of 1962 in Burkina Faso to that in Central African Republic?
Give a very brief answer. 1.27. What is the ratio of the Imports (in Local Currency Unit) in 1963 in Burkina Faso to that in Central African Republic?
Offer a very short reply. 1.24. What is the ratio of the Imports (in Local Currency Unit) of 1960 in Burundi to that in Canada?
Your answer should be very brief. 0.18. What is the ratio of the Imports (in Local Currency Unit) of 1961 in Burundi to that in Canada?
Give a very brief answer. 0.2. What is the ratio of the Imports (in Local Currency Unit) of 1962 in Burundi to that in Canada?
Give a very brief answer. 0.22. What is the ratio of the Imports (in Local Currency Unit) in 1963 in Burundi to that in Canada?
Your answer should be compact. 0.2. What is the ratio of the Imports (in Local Currency Unit) in 1960 in Burundi to that in Central African Republic?
Ensure brevity in your answer.  0.14. What is the ratio of the Imports (in Local Currency Unit) of 1961 in Burundi to that in Central African Republic?
Offer a terse response. 0.14. What is the ratio of the Imports (in Local Currency Unit) in 1962 in Burundi to that in Central African Republic?
Provide a short and direct response. 0.15. What is the ratio of the Imports (in Local Currency Unit) of 1963 in Burundi to that in Central African Republic?
Your response must be concise. 0.14. What is the ratio of the Imports (in Local Currency Unit) of 1960 in Canada to that in Central African Republic?
Make the answer very short. 0.77. What is the ratio of the Imports (in Local Currency Unit) of 1961 in Canada to that in Central African Republic?
Provide a short and direct response. 0.69. What is the ratio of the Imports (in Local Currency Unit) in 1962 in Canada to that in Central African Republic?
Ensure brevity in your answer.  0.69. What is the ratio of the Imports (in Local Currency Unit) in 1963 in Canada to that in Central African Republic?
Make the answer very short. 0.69. What is the difference between the highest and the second highest Imports (in Local Currency Unit) of 1960?
Your response must be concise. 3.43e+09. What is the difference between the highest and the second highest Imports (in Local Currency Unit) in 1961?
Ensure brevity in your answer.  2.76e+09. What is the difference between the highest and the second highest Imports (in Local Currency Unit) in 1962?
Your answer should be compact. 3.11e+09. What is the difference between the highest and the second highest Imports (in Local Currency Unit) in 1963?
Make the answer very short. 2.93e+09. What is the difference between the highest and the lowest Imports (in Local Currency Unit) in 1960?
Keep it short and to the point. 1.28e+1. What is the difference between the highest and the lowest Imports (in Local Currency Unit) of 1961?
Your response must be concise. 1.36e+1. What is the difference between the highest and the lowest Imports (in Local Currency Unit) in 1962?
Offer a terse response. 1.46e+1. What is the difference between the highest and the lowest Imports (in Local Currency Unit) in 1963?
Offer a very short reply. 1.51e+1. 